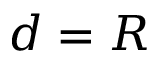Convert formula to latex. <formula><loc_0><loc_0><loc_500><loc_500>d = R</formula> 